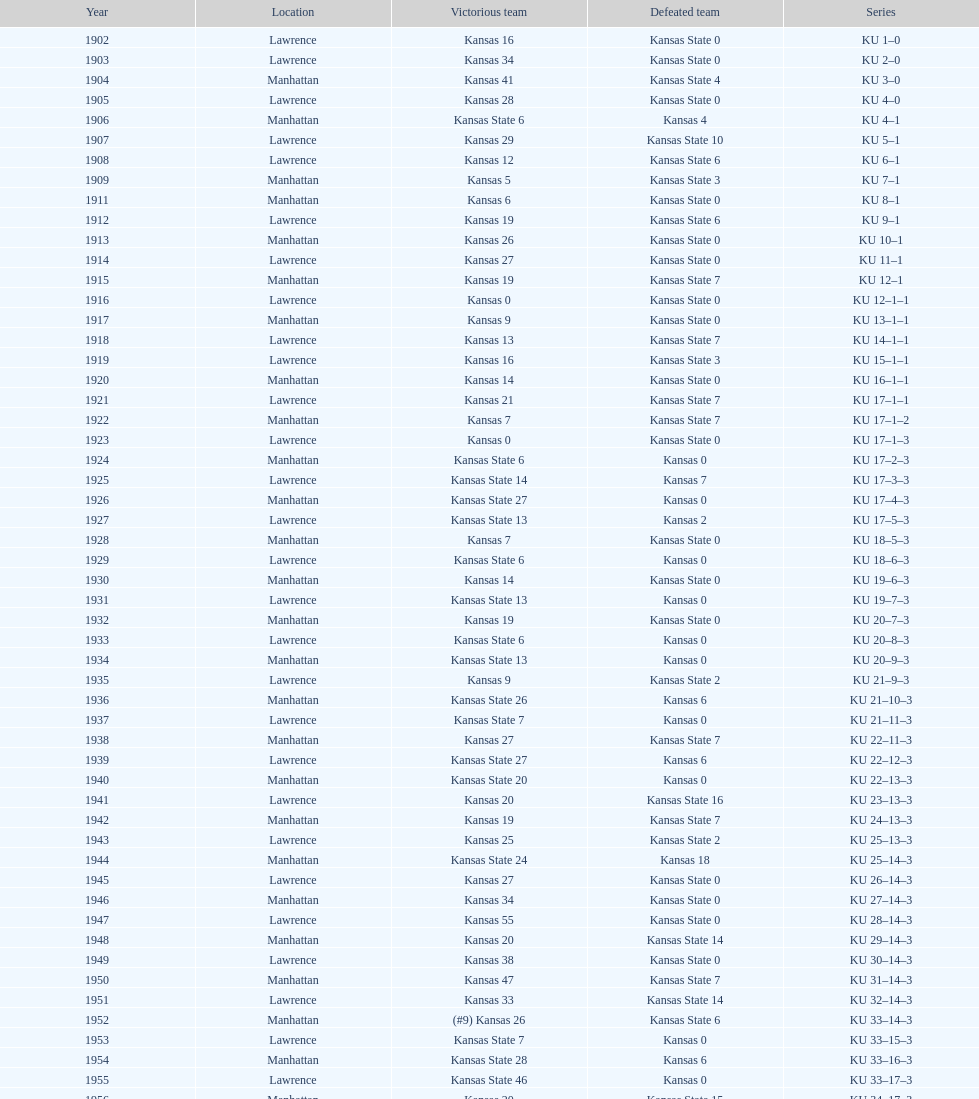How many times did kansas and kansas state play in lawrence from 1902-1968? 34. 